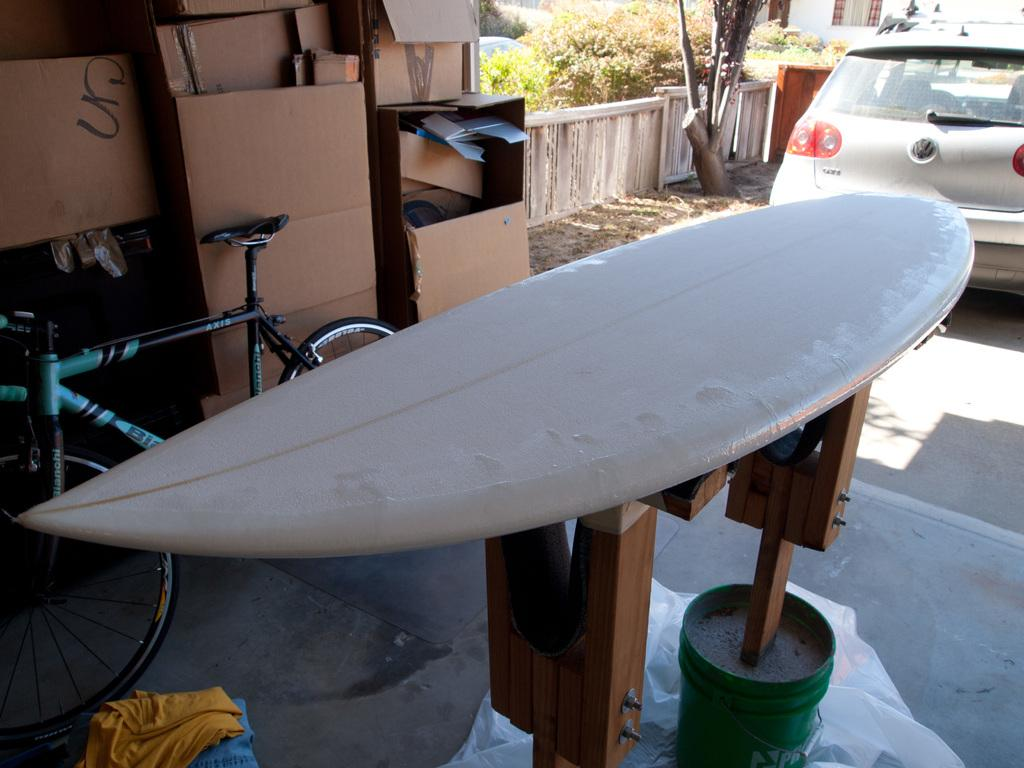What type of sports equipment is visible in the image? There is a surfing board in the image. What other mode of transportation can be seen in the image? There is a bicycle in the image. What materials are present in the image that might be used for crafting or building? There are cardboard pieces in the image. What type of vehicle is on the right side of the image? There is a car on the right side of the image. What type of natural environment is visible in the background of the image? There are trees in the background of the image. What architectural feature is visible in the background of the image? There is a fence in the background of the image. Where is the crib located in the image? There is no crib present in the image. What type of zipper is used on the surfing board in the image? There are no zippers on the surfing board in the image. What type of club is visible in the image? There is no club present in the image. 